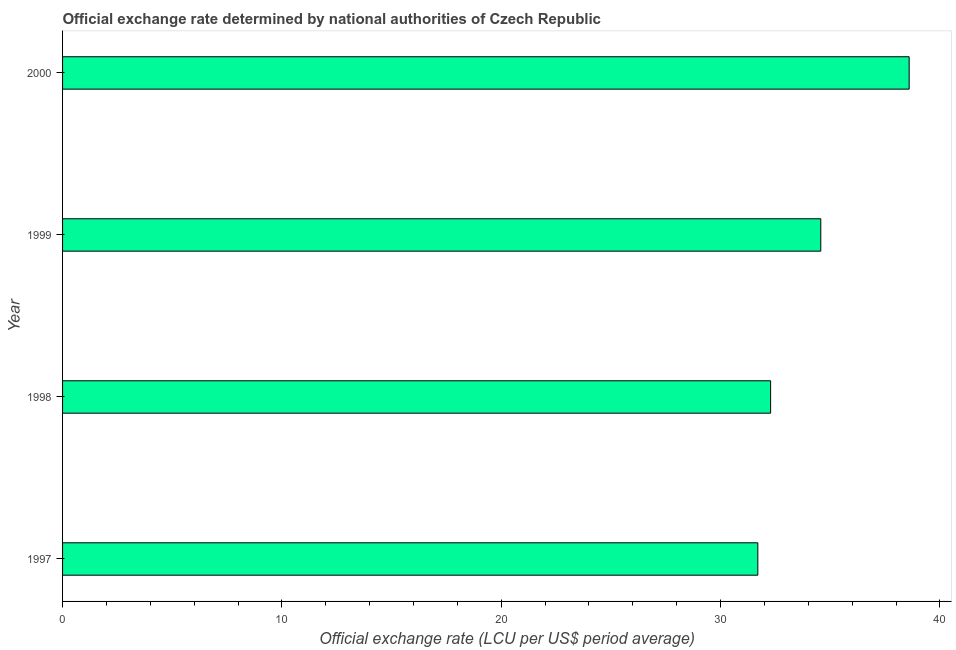What is the title of the graph?
Offer a terse response. Official exchange rate determined by national authorities of Czech Republic. What is the label or title of the X-axis?
Make the answer very short. Official exchange rate (LCU per US$ period average). What is the official exchange rate in 1999?
Make the answer very short. 34.57. Across all years, what is the maximum official exchange rate?
Provide a short and direct response. 38.6. Across all years, what is the minimum official exchange rate?
Offer a very short reply. 31.7. In which year was the official exchange rate minimum?
Provide a succinct answer. 1997. What is the sum of the official exchange rate?
Your answer should be compact. 137.15. What is the difference between the official exchange rate in 1997 and 1998?
Ensure brevity in your answer.  -0.58. What is the average official exchange rate per year?
Keep it short and to the point. 34.29. What is the median official exchange rate?
Keep it short and to the point. 33.43. Do a majority of the years between 1999 and 1998 (inclusive) have official exchange rate greater than 4 ?
Offer a very short reply. No. Is the difference between the official exchange rate in 1997 and 1999 greater than the difference between any two years?
Your answer should be very brief. No. What is the difference between the highest and the second highest official exchange rate?
Offer a very short reply. 4.03. Is the sum of the official exchange rate in 1997 and 1998 greater than the maximum official exchange rate across all years?
Keep it short and to the point. Yes. In how many years, is the official exchange rate greater than the average official exchange rate taken over all years?
Offer a very short reply. 2. How many years are there in the graph?
Provide a short and direct response. 4. What is the Official exchange rate (LCU per US$ period average) of 1997?
Provide a succinct answer. 31.7. What is the Official exchange rate (LCU per US$ period average) in 1998?
Provide a succinct answer. 32.28. What is the Official exchange rate (LCU per US$ period average) of 1999?
Offer a terse response. 34.57. What is the Official exchange rate (LCU per US$ period average) of 2000?
Offer a very short reply. 38.6. What is the difference between the Official exchange rate (LCU per US$ period average) in 1997 and 1998?
Keep it short and to the point. -0.58. What is the difference between the Official exchange rate (LCU per US$ period average) in 1997 and 1999?
Provide a succinct answer. -2.87. What is the difference between the Official exchange rate (LCU per US$ period average) in 1997 and 2000?
Your response must be concise. -6.9. What is the difference between the Official exchange rate (LCU per US$ period average) in 1998 and 1999?
Ensure brevity in your answer.  -2.29. What is the difference between the Official exchange rate (LCU per US$ period average) in 1998 and 2000?
Your answer should be compact. -6.32. What is the difference between the Official exchange rate (LCU per US$ period average) in 1999 and 2000?
Offer a very short reply. -4.03. What is the ratio of the Official exchange rate (LCU per US$ period average) in 1997 to that in 1999?
Offer a terse response. 0.92. What is the ratio of the Official exchange rate (LCU per US$ period average) in 1997 to that in 2000?
Your answer should be compact. 0.82. What is the ratio of the Official exchange rate (LCU per US$ period average) in 1998 to that in 1999?
Offer a terse response. 0.93. What is the ratio of the Official exchange rate (LCU per US$ period average) in 1998 to that in 2000?
Provide a succinct answer. 0.84. What is the ratio of the Official exchange rate (LCU per US$ period average) in 1999 to that in 2000?
Provide a short and direct response. 0.9. 